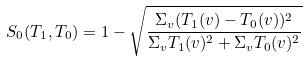Convert formula to latex. <formula><loc_0><loc_0><loc_500><loc_500>S _ { 0 } ( T _ { 1 } , T _ { 0 } ) = 1 - \sqrt { \frac { \Sigma _ { v } ( T _ { 1 } ( v ) - T _ { 0 } ( v ) ) ^ { 2 } } { \Sigma _ { v } T _ { 1 } ( v ) ^ { 2 } + \Sigma _ { v } T _ { 0 } ( v ) ^ { 2 } } }</formula> 